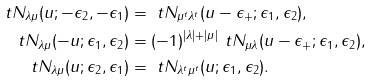Convert formula to latex. <formula><loc_0><loc_0><loc_500><loc_500>\ t N _ { \lambda \mu } ( u ; - \epsilon _ { 2 } , - \epsilon _ { 1 } ) & = \ t N _ { \mu ^ { t } \lambda ^ { t } } ( u - \epsilon _ { + } ; \epsilon _ { 1 } , \epsilon _ { 2 } ) , \\ \ t N _ { \lambda \mu } ( - u ; \epsilon _ { 1 } , \epsilon _ { 2 } ) & = ( - 1 ) ^ { | \lambda | + | \mu | } \ t N _ { \mu \lambda } ( u - \epsilon _ { + } ; \epsilon _ { 1 } , \epsilon _ { 2 } ) , \\ \ t N _ { \lambda \mu } ( u ; \epsilon _ { 2 } , \epsilon _ { 1 } ) & = \ t N _ { \lambda ^ { t } \mu ^ { t } } ( u ; \epsilon _ { 1 } , \epsilon _ { 2 } ) .</formula> 